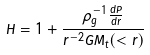<formula> <loc_0><loc_0><loc_500><loc_500>H = 1 + \frac { \rho _ { g } ^ { - 1 } \frac { d P } { d r } } { r ^ { - 2 } G M _ { t } ( < r ) }</formula> 